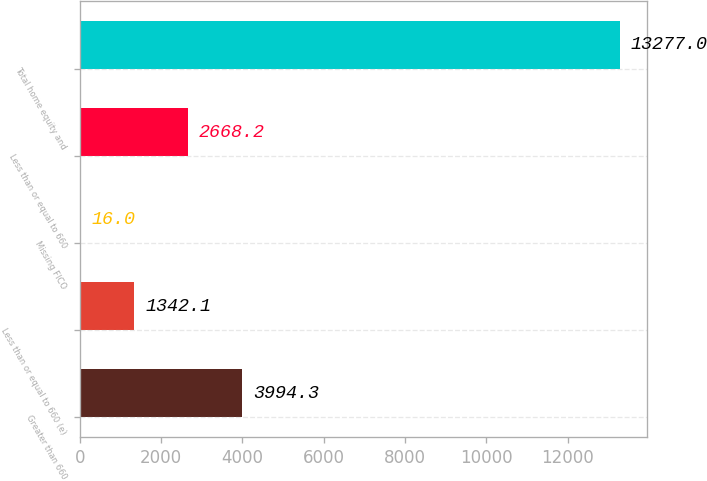Convert chart. <chart><loc_0><loc_0><loc_500><loc_500><bar_chart><fcel>Greater than 660<fcel>Less than or equal to 660 (e)<fcel>Missing FICO<fcel>Less than or equal to 660<fcel>Total home equity and<nl><fcel>3994.3<fcel>1342.1<fcel>16<fcel>2668.2<fcel>13277<nl></chart> 